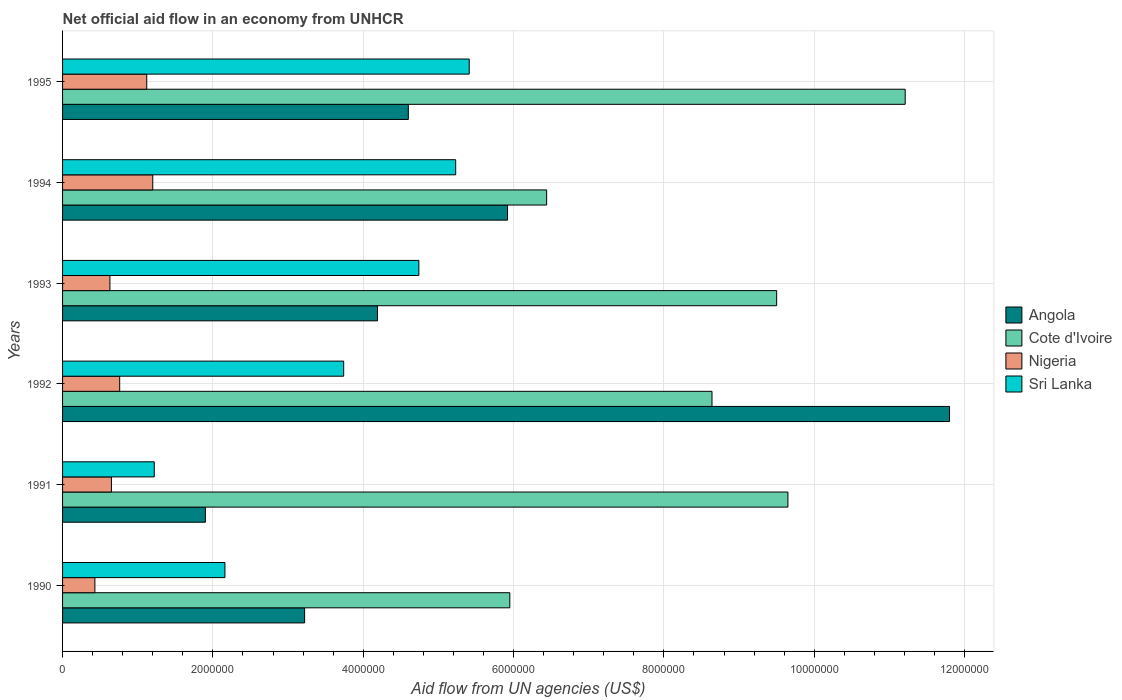How many different coloured bars are there?
Offer a terse response. 4. How many groups of bars are there?
Your answer should be compact. 6. Are the number of bars per tick equal to the number of legend labels?
Offer a very short reply. Yes. How many bars are there on the 5th tick from the bottom?
Offer a very short reply. 4. In how many cases, is the number of bars for a given year not equal to the number of legend labels?
Your response must be concise. 0. Across all years, what is the maximum net official aid flow in Sri Lanka?
Your answer should be compact. 5.41e+06. Across all years, what is the minimum net official aid flow in Angola?
Ensure brevity in your answer.  1.90e+06. In which year was the net official aid flow in Cote d'Ivoire maximum?
Your response must be concise. 1995. In which year was the net official aid flow in Angola minimum?
Provide a succinct answer. 1991. What is the total net official aid flow in Nigeria in the graph?
Offer a very short reply. 4.79e+06. What is the difference between the net official aid flow in Sri Lanka in 1990 and that in 1993?
Keep it short and to the point. -2.58e+06. What is the difference between the net official aid flow in Cote d'Ivoire in 1992 and the net official aid flow in Sri Lanka in 1995?
Keep it short and to the point. 3.23e+06. What is the average net official aid flow in Angola per year?
Give a very brief answer. 5.27e+06. In the year 1994, what is the difference between the net official aid flow in Cote d'Ivoire and net official aid flow in Angola?
Make the answer very short. 5.20e+05. In how many years, is the net official aid flow in Nigeria greater than 9600000 US$?
Provide a short and direct response. 0. What is the ratio of the net official aid flow in Sri Lanka in 1993 to that in 1994?
Make the answer very short. 0.91. Is the net official aid flow in Sri Lanka in 1990 less than that in 1991?
Make the answer very short. No. Is the difference between the net official aid flow in Cote d'Ivoire in 1990 and 1994 greater than the difference between the net official aid flow in Angola in 1990 and 1994?
Offer a terse response. Yes. What is the difference between the highest and the second highest net official aid flow in Angola?
Provide a succinct answer. 5.88e+06. What is the difference between the highest and the lowest net official aid flow in Angola?
Your answer should be very brief. 9.90e+06. What does the 1st bar from the top in 1992 represents?
Ensure brevity in your answer.  Sri Lanka. What does the 4th bar from the bottom in 1992 represents?
Provide a succinct answer. Sri Lanka. Are all the bars in the graph horizontal?
Provide a short and direct response. Yes. What is the difference between two consecutive major ticks on the X-axis?
Keep it short and to the point. 2.00e+06. Are the values on the major ticks of X-axis written in scientific E-notation?
Ensure brevity in your answer.  No. Does the graph contain any zero values?
Your answer should be very brief. No. Does the graph contain grids?
Provide a succinct answer. Yes. Where does the legend appear in the graph?
Provide a short and direct response. Center right. What is the title of the graph?
Ensure brevity in your answer.  Net official aid flow in an economy from UNHCR. What is the label or title of the X-axis?
Offer a terse response. Aid flow from UN agencies (US$). What is the Aid flow from UN agencies (US$) in Angola in 1990?
Provide a short and direct response. 3.22e+06. What is the Aid flow from UN agencies (US$) of Cote d'Ivoire in 1990?
Offer a terse response. 5.95e+06. What is the Aid flow from UN agencies (US$) of Sri Lanka in 1990?
Provide a succinct answer. 2.16e+06. What is the Aid flow from UN agencies (US$) of Angola in 1991?
Your response must be concise. 1.90e+06. What is the Aid flow from UN agencies (US$) in Cote d'Ivoire in 1991?
Make the answer very short. 9.65e+06. What is the Aid flow from UN agencies (US$) in Nigeria in 1991?
Offer a terse response. 6.50e+05. What is the Aid flow from UN agencies (US$) of Sri Lanka in 1991?
Your response must be concise. 1.22e+06. What is the Aid flow from UN agencies (US$) of Angola in 1992?
Offer a very short reply. 1.18e+07. What is the Aid flow from UN agencies (US$) of Cote d'Ivoire in 1992?
Provide a succinct answer. 8.64e+06. What is the Aid flow from UN agencies (US$) in Nigeria in 1992?
Provide a succinct answer. 7.60e+05. What is the Aid flow from UN agencies (US$) in Sri Lanka in 1992?
Your answer should be compact. 3.74e+06. What is the Aid flow from UN agencies (US$) in Angola in 1993?
Provide a succinct answer. 4.19e+06. What is the Aid flow from UN agencies (US$) of Cote d'Ivoire in 1993?
Your answer should be compact. 9.50e+06. What is the Aid flow from UN agencies (US$) of Nigeria in 1993?
Provide a short and direct response. 6.30e+05. What is the Aid flow from UN agencies (US$) in Sri Lanka in 1993?
Offer a terse response. 4.74e+06. What is the Aid flow from UN agencies (US$) in Angola in 1994?
Keep it short and to the point. 5.92e+06. What is the Aid flow from UN agencies (US$) of Cote d'Ivoire in 1994?
Offer a terse response. 6.44e+06. What is the Aid flow from UN agencies (US$) in Nigeria in 1994?
Make the answer very short. 1.20e+06. What is the Aid flow from UN agencies (US$) of Sri Lanka in 1994?
Ensure brevity in your answer.  5.23e+06. What is the Aid flow from UN agencies (US$) in Angola in 1995?
Give a very brief answer. 4.60e+06. What is the Aid flow from UN agencies (US$) of Cote d'Ivoire in 1995?
Make the answer very short. 1.12e+07. What is the Aid flow from UN agencies (US$) of Nigeria in 1995?
Your response must be concise. 1.12e+06. What is the Aid flow from UN agencies (US$) of Sri Lanka in 1995?
Keep it short and to the point. 5.41e+06. Across all years, what is the maximum Aid flow from UN agencies (US$) of Angola?
Ensure brevity in your answer.  1.18e+07. Across all years, what is the maximum Aid flow from UN agencies (US$) in Cote d'Ivoire?
Offer a very short reply. 1.12e+07. Across all years, what is the maximum Aid flow from UN agencies (US$) of Nigeria?
Provide a short and direct response. 1.20e+06. Across all years, what is the maximum Aid flow from UN agencies (US$) in Sri Lanka?
Give a very brief answer. 5.41e+06. Across all years, what is the minimum Aid flow from UN agencies (US$) of Angola?
Make the answer very short. 1.90e+06. Across all years, what is the minimum Aid flow from UN agencies (US$) of Cote d'Ivoire?
Make the answer very short. 5.95e+06. Across all years, what is the minimum Aid flow from UN agencies (US$) of Sri Lanka?
Give a very brief answer. 1.22e+06. What is the total Aid flow from UN agencies (US$) in Angola in the graph?
Give a very brief answer. 3.16e+07. What is the total Aid flow from UN agencies (US$) in Cote d'Ivoire in the graph?
Your response must be concise. 5.14e+07. What is the total Aid flow from UN agencies (US$) of Nigeria in the graph?
Keep it short and to the point. 4.79e+06. What is the total Aid flow from UN agencies (US$) of Sri Lanka in the graph?
Offer a very short reply. 2.25e+07. What is the difference between the Aid flow from UN agencies (US$) of Angola in 1990 and that in 1991?
Provide a succinct answer. 1.32e+06. What is the difference between the Aid flow from UN agencies (US$) in Cote d'Ivoire in 1990 and that in 1991?
Your answer should be very brief. -3.70e+06. What is the difference between the Aid flow from UN agencies (US$) of Sri Lanka in 1990 and that in 1991?
Make the answer very short. 9.40e+05. What is the difference between the Aid flow from UN agencies (US$) of Angola in 1990 and that in 1992?
Provide a short and direct response. -8.58e+06. What is the difference between the Aid flow from UN agencies (US$) in Cote d'Ivoire in 1990 and that in 1992?
Your answer should be compact. -2.69e+06. What is the difference between the Aid flow from UN agencies (US$) in Nigeria in 1990 and that in 1992?
Your answer should be very brief. -3.30e+05. What is the difference between the Aid flow from UN agencies (US$) of Sri Lanka in 1990 and that in 1992?
Give a very brief answer. -1.58e+06. What is the difference between the Aid flow from UN agencies (US$) of Angola in 1990 and that in 1993?
Your response must be concise. -9.70e+05. What is the difference between the Aid flow from UN agencies (US$) in Cote d'Ivoire in 1990 and that in 1993?
Give a very brief answer. -3.55e+06. What is the difference between the Aid flow from UN agencies (US$) of Nigeria in 1990 and that in 1993?
Give a very brief answer. -2.00e+05. What is the difference between the Aid flow from UN agencies (US$) of Sri Lanka in 1990 and that in 1993?
Provide a short and direct response. -2.58e+06. What is the difference between the Aid flow from UN agencies (US$) of Angola in 1990 and that in 1994?
Provide a succinct answer. -2.70e+06. What is the difference between the Aid flow from UN agencies (US$) in Cote d'Ivoire in 1990 and that in 1994?
Give a very brief answer. -4.90e+05. What is the difference between the Aid flow from UN agencies (US$) in Nigeria in 1990 and that in 1994?
Ensure brevity in your answer.  -7.70e+05. What is the difference between the Aid flow from UN agencies (US$) of Sri Lanka in 1990 and that in 1994?
Make the answer very short. -3.07e+06. What is the difference between the Aid flow from UN agencies (US$) of Angola in 1990 and that in 1995?
Provide a short and direct response. -1.38e+06. What is the difference between the Aid flow from UN agencies (US$) in Cote d'Ivoire in 1990 and that in 1995?
Make the answer very short. -5.26e+06. What is the difference between the Aid flow from UN agencies (US$) of Nigeria in 1990 and that in 1995?
Offer a very short reply. -6.90e+05. What is the difference between the Aid flow from UN agencies (US$) in Sri Lanka in 1990 and that in 1995?
Offer a very short reply. -3.25e+06. What is the difference between the Aid flow from UN agencies (US$) in Angola in 1991 and that in 1992?
Offer a terse response. -9.90e+06. What is the difference between the Aid flow from UN agencies (US$) in Cote d'Ivoire in 1991 and that in 1992?
Make the answer very short. 1.01e+06. What is the difference between the Aid flow from UN agencies (US$) of Sri Lanka in 1991 and that in 1992?
Offer a terse response. -2.52e+06. What is the difference between the Aid flow from UN agencies (US$) of Angola in 1991 and that in 1993?
Give a very brief answer. -2.29e+06. What is the difference between the Aid flow from UN agencies (US$) of Sri Lanka in 1991 and that in 1993?
Make the answer very short. -3.52e+06. What is the difference between the Aid flow from UN agencies (US$) in Angola in 1991 and that in 1994?
Offer a terse response. -4.02e+06. What is the difference between the Aid flow from UN agencies (US$) in Cote d'Ivoire in 1991 and that in 1994?
Offer a very short reply. 3.21e+06. What is the difference between the Aid flow from UN agencies (US$) of Nigeria in 1991 and that in 1994?
Provide a succinct answer. -5.50e+05. What is the difference between the Aid flow from UN agencies (US$) in Sri Lanka in 1991 and that in 1994?
Your response must be concise. -4.01e+06. What is the difference between the Aid flow from UN agencies (US$) of Angola in 1991 and that in 1995?
Ensure brevity in your answer.  -2.70e+06. What is the difference between the Aid flow from UN agencies (US$) in Cote d'Ivoire in 1991 and that in 1995?
Your answer should be very brief. -1.56e+06. What is the difference between the Aid flow from UN agencies (US$) in Nigeria in 1991 and that in 1995?
Offer a very short reply. -4.70e+05. What is the difference between the Aid flow from UN agencies (US$) in Sri Lanka in 1991 and that in 1995?
Provide a succinct answer. -4.19e+06. What is the difference between the Aid flow from UN agencies (US$) of Angola in 1992 and that in 1993?
Offer a terse response. 7.61e+06. What is the difference between the Aid flow from UN agencies (US$) in Cote d'Ivoire in 1992 and that in 1993?
Keep it short and to the point. -8.60e+05. What is the difference between the Aid flow from UN agencies (US$) in Angola in 1992 and that in 1994?
Your answer should be compact. 5.88e+06. What is the difference between the Aid flow from UN agencies (US$) in Cote d'Ivoire in 1992 and that in 1994?
Your response must be concise. 2.20e+06. What is the difference between the Aid flow from UN agencies (US$) in Nigeria in 1992 and that in 1994?
Offer a very short reply. -4.40e+05. What is the difference between the Aid flow from UN agencies (US$) of Sri Lanka in 1992 and that in 1994?
Give a very brief answer. -1.49e+06. What is the difference between the Aid flow from UN agencies (US$) of Angola in 1992 and that in 1995?
Offer a terse response. 7.20e+06. What is the difference between the Aid flow from UN agencies (US$) of Cote d'Ivoire in 1992 and that in 1995?
Your answer should be very brief. -2.57e+06. What is the difference between the Aid flow from UN agencies (US$) in Nigeria in 1992 and that in 1995?
Offer a very short reply. -3.60e+05. What is the difference between the Aid flow from UN agencies (US$) of Sri Lanka in 1992 and that in 1995?
Give a very brief answer. -1.67e+06. What is the difference between the Aid flow from UN agencies (US$) of Angola in 1993 and that in 1994?
Keep it short and to the point. -1.73e+06. What is the difference between the Aid flow from UN agencies (US$) in Cote d'Ivoire in 1993 and that in 1994?
Ensure brevity in your answer.  3.06e+06. What is the difference between the Aid flow from UN agencies (US$) of Nigeria in 1993 and that in 1994?
Provide a short and direct response. -5.70e+05. What is the difference between the Aid flow from UN agencies (US$) of Sri Lanka in 1993 and that in 1994?
Your answer should be compact. -4.90e+05. What is the difference between the Aid flow from UN agencies (US$) of Angola in 1993 and that in 1995?
Make the answer very short. -4.10e+05. What is the difference between the Aid flow from UN agencies (US$) of Cote d'Ivoire in 1993 and that in 1995?
Your response must be concise. -1.71e+06. What is the difference between the Aid flow from UN agencies (US$) in Nigeria in 1993 and that in 1995?
Keep it short and to the point. -4.90e+05. What is the difference between the Aid flow from UN agencies (US$) in Sri Lanka in 1993 and that in 1995?
Your answer should be very brief. -6.70e+05. What is the difference between the Aid flow from UN agencies (US$) of Angola in 1994 and that in 1995?
Make the answer very short. 1.32e+06. What is the difference between the Aid flow from UN agencies (US$) of Cote d'Ivoire in 1994 and that in 1995?
Make the answer very short. -4.77e+06. What is the difference between the Aid flow from UN agencies (US$) of Sri Lanka in 1994 and that in 1995?
Ensure brevity in your answer.  -1.80e+05. What is the difference between the Aid flow from UN agencies (US$) of Angola in 1990 and the Aid flow from UN agencies (US$) of Cote d'Ivoire in 1991?
Your answer should be compact. -6.43e+06. What is the difference between the Aid flow from UN agencies (US$) of Angola in 1990 and the Aid flow from UN agencies (US$) of Nigeria in 1991?
Your answer should be very brief. 2.57e+06. What is the difference between the Aid flow from UN agencies (US$) in Cote d'Ivoire in 1990 and the Aid flow from UN agencies (US$) in Nigeria in 1991?
Ensure brevity in your answer.  5.30e+06. What is the difference between the Aid flow from UN agencies (US$) of Cote d'Ivoire in 1990 and the Aid flow from UN agencies (US$) of Sri Lanka in 1991?
Your response must be concise. 4.73e+06. What is the difference between the Aid flow from UN agencies (US$) of Nigeria in 1990 and the Aid flow from UN agencies (US$) of Sri Lanka in 1991?
Offer a terse response. -7.90e+05. What is the difference between the Aid flow from UN agencies (US$) in Angola in 1990 and the Aid flow from UN agencies (US$) in Cote d'Ivoire in 1992?
Offer a very short reply. -5.42e+06. What is the difference between the Aid flow from UN agencies (US$) in Angola in 1990 and the Aid flow from UN agencies (US$) in Nigeria in 1992?
Your answer should be very brief. 2.46e+06. What is the difference between the Aid flow from UN agencies (US$) in Angola in 1990 and the Aid flow from UN agencies (US$) in Sri Lanka in 1992?
Ensure brevity in your answer.  -5.20e+05. What is the difference between the Aid flow from UN agencies (US$) of Cote d'Ivoire in 1990 and the Aid flow from UN agencies (US$) of Nigeria in 1992?
Keep it short and to the point. 5.19e+06. What is the difference between the Aid flow from UN agencies (US$) in Cote d'Ivoire in 1990 and the Aid flow from UN agencies (US$) in Sri Lanka in 1992?
Your answer should be very brief. 2.21e+06. What is the difference between the Aid flow from UN agencies (US$) in Nigeria in 1990 and the Aid flow from UN agencies (US$) in Sri Lanka in 1992?
Keep it short and to the point. -3.31e+06. What is the difference between the Aid flow from UN agencies (US$) in Angola in 1990 and the Aid flow from UN agencies (US$) in Cote d'Ivoire in 1993?
Offer a terse response. -6.28e+06. What is the difference between the Aid flow from UN agencies (US$) of Angola in 1990 and the Aid flow from UN agencies (US$) of Nigeria in 1993?
Provide a succinct answer. 2.59e+06. What is the difference between the Aid flow from UN agencies (US$) of Angola in 1990 and the Aid flow from UN agencies (US$) of Sri Lanka in 1993?
Your answer should be compact. -1.52e+06. What is the difference between the Aid flow from UN agencies (US$) of Cote d'Ivoire in 1990 and the Aid flow from UN agencies (US$) of Nigeria in 1993?
Give a very brief answer. 5.32e+06. What is the difference between the Aid flow from UN agencies (US$) of Cote d'Ivoire in 1990 and the Aid flow from UN agencies (US$) of Sri Lanka in 1993?
Provide a succinct answer. 1.21e+06. What is the difference between the Aid flow from UN agencies (US$) of Nigeria in 1990 and the Aid flow from UN agencies (US$) of Sri Lanka in 1993?
Your answer should be very brief. -4.31e+06. What is the difference between the Aid flow from UN agencies (US$) in Angola in 1990 and the Aid flow from UN agencies (US$) in Cote d'Ivoire in 1994?
Give a very brief answer. -3.22e+06. What is the difference between the Aid flow from UN agencies (US$) of Angola in 1990 and the Aid flow from UN agencies (US$) of Nigeria in 1994?
Ensure brevity in your answer.  2.02e+06. What is the difference between the Aid flow from UN agencies (US$) of Angola in 1990 and the Aid flow from UN agencies (US$) of Sri Lanka in 1994?
Your answer should be compact. -2.01e+06. What is the difference between the Aid flow from UN agencies (US$) in Cote d'Ivoire in 1990 and the Aid flow from UN agencies (US$) in Nigeria in 1994?
Your answer should be compact. 4.75e+06. What is the difference between the Aid flow from UN agencies (US$) of Cote d'Ivoire in 1990 and the Aid flow from UN agencies (US$) of Sri Lanka in 1994?
Provide a short and direct response. 7.20e+05. What is the difference between the Aid flow from UN agencies (US$) of Nigeria in 1990 and the Aid flow from UN agencies (US$) of Sri Lanka in 1994?
Make the answer very short. -4.80e+06. What is the difference between the Aid flow from UN agencies (US$) of Angola in 1990 and the Aid flow from UN agencies (US$) of Cote d'Ivoire in 1995?
Your answer should be very brief. -7.99e+06. What is the difference between the Aid flow from UN agencies (US$) in Angola in 1990 and the Aid flow from UN agencies (US$) in Nigeria in 1995?
Give a very brief answer. 2.10e+06. What is the difference between the Aid flow from UN agencies (US$) of Angola in 1990 and the Aid flow from UN agencies (US$) of Sri Lanka in 1995?
Your response must be concise. -2.19e+06. What is the difference between the Aid flow from UN agencies (US$) of Cote d'Ivoire in 1990 and the Aid flow from UN agencies (US$) of Nigeria in 1995?
Provide a succinct answer. 4.83e+06. What is the difference between the Aid flow from UN agencies (US$) in Cote d'Ivoire in 1990 and the Aid flow from UN agencies (US$) in Sri Lanka in 1995?
Provide a succinct answer. 5.40e+05. What is the difference between the Aid flow from UN agencies (US$) in Nigeria in 1990 and the Aid flow from UN agencies (US$) in Sri Lanka in 1995?
Keep it short and to the point. -4.98e+06. What is the difference between the Aid flow from UN agencies (US$) of Angola in 1991 and the Aid flow from UN agencies (US$) of Cote d'Ivoire in 1992?
Your answer should be compact. -6.74e+06. What is the difference between the Aid flow from UN agencies (US$) of Angola in 1991 and the Aid flow from UN agencies (US$) of Nigeria in 1992?
Your answer should be very brief. 1.14e+06. What is the difference between the Aid flow from UN agencies (US$) of Angola in 1991 and the Aid flow from UN agencies (US$) of Sri Lanka in 1992?
Your answer should be compact. -1.84e+06. What is the difference between the Aid flow from UN agencies (US$) of Cote d'Ivoire in 1991 and the Aid flow from UN agencies (US$) of Nigeria in 1992?
Ensure brevity in your answer.  8.89e+06. What is the difference between the Aid flow from UN agencies (US$) of Cote d'Ivoire in 1991 and the Aid flow from UN agencies (US$) of Sri Lanka in 1992?
Give a very brief answer. 5.91e+06. What is the difference between the Aid flow from UN agencies (US$) of Nigeria in 1991 and the Aid flow from UN agencies (US$) of Sri Lanka in 1992?
Provide a succinct answer. -3.09e+06. What is the difference between the Aid flow from UN agencies (US$) of Angola in 1991 and the Aid flow from UN agencies (US$) of Cote d'Ivoire in 1993?
Your response must be concise. -7.60e+06. What is the difference between the Aid flow from UN agencies (US$) of Angola in 1991 and the Aid flow from UN agencies (US$) of Nigeria in 1993?
Make the answer very short. 1.27e+06. What is the difference between the Aid flow from UN agencies (US$) in Angola in 1991 and the Aid flow from UN agencies (US$) in Sri Lanka in 1993?
Ensure brevity in your answer.  -2.84e+06. What is the difference between the Aid flow from UN agencies (US$) of Cote d'Ivoire in 1991 and the Aid flow from UN agencies (US$) of Nigeria in 1993?
Your answer should be very brief. 9.02e+06. What is the difference between the Aid flow from UN agencies (US$) in Cote d'Ivoire in 1991 and the Aid flow from UN agencies (US$) in Sri Lanka in 1993?
Make the answer very short. 4.91e+06. What is the difference between the Aid flow from UN agencies (US$) of Nigeria in 1991 and the Aid flow from UN agencies (US$) of Sri Lanka in 1993?
Your answer should be very brief. -4.09e+06. What is the difference between the Aid flow from UN agencies (US$) of Angola in 1991 and the Aid flow from UN agencies (US$) of Cote d'Ivoire in 1994?
Your response must be concise. -4.54e+06. What is the difference between the Aid flow from UN agencies (US$) in Angola in 1991 and the Aid flow from UN agencies (US$) in Nigeria in 1994?
Ensure brevity in your answer.  7.00e+05. What is the difference between the Aid flow from UN agencies (US$) of Angola in 1991 and the Aid flow from UN agencies (US$) of Sri Lanka in 1994?
Offer a very short reply. -3.33e+06. What is the difference between the Aid flow from UN agencies (US$) in Cote d'Ivoire in 1991 and the Aid flow from UN agencies (US$) in Nigeria in 1994?
Ensure brevity in your answer.  8.45e+06. What is the difference between the Aid flow from UN agencies (US$) in Cote d'Ivoire in 1991 and the Aid flow from UN agencies (US$) in Sri Lanka in 1994?
Your answer should be compact. 4.42e+06. What is the difference between the Aid flow from UN agencies (US$) in Nigeria in 1991 and the Aid flow from UN agencies (US$) in Sri Lanka in 1994?
Ensure brevity in your answer.  -4.58e+06. What is the difference between the Aid flow from UN agencies (US$) in Angola in 1991 and the Aid flow from UN agencies (US$) in Cote d'Ivoire in 1995?
Keep it short and to the point. -9.31e+06. What is the difference between the Aid flow from UN agencies (US$) of Angola in 1991 and the Aid flow from UN agencies (US$) of Nigeria in 1995?
Ensure brevity in your answer.  7.80e+05. What is the difference between the Aid flow from UN agencies (US$) of Angola in 1991 and the Aid flow from UN agencies (US$) of Sri Lanka in 1995?
Your response must be concise. -3.51e+06. What is the difference between the Aid flow from UN agencies (US$) in Cote d'Ivoire in 1991 and the Aid flow from UN agencies (US$) in Nigeria in 1995?
Make the answer very short. 8.53e+06. What is the difference between the Aid flow from UN agencies (US$) in Cote d'Ivoire in 1991 and the Aid flow from UN agencies (US$) in Sri Lanka in 1995?
Your answer should be very brief. 4.24e+06. What is the difference between the Aid flow from UN agencies (US$) of Nigeria in 1991 and the Aid flow from UN agencies (US$) of Sri Lanka in 1995?
Make the answer very short. -4.76e+06. What is the difference between the Aid flow from UN agencies (US$) in Angola in 1992 and the Aid flow from UN agencies (US$) in Cote d'Ivoire in 1993?
Offer a terse response. 2.30e+06. What is the difference between the Aid flow from UN agencies (US$) in Angola in 1992 and the Aid flow from UN agencies (US$) in Nigeria in 1993?
Keep it short and to the point. 1.12e+07. What is the difference between the Aid flow from UN agencies (US$) in Angola in 1992 and the Aid flow from UN agencies (US$) in Sri Lanka in 1993?
Make the answer very short. 7.06e+06. What is the difference between the Aid flow from UN agencies (US$) in Cote d'Ivoire in 1992 and the Aid flow from UN agencies (US$) in Nigeria in 1993?
Your answer should be compact. 8.01e+06. What is the difference between the Aid flow from UN agencies (US$) in Cote d'Ivoire in 1992 and the Aid flow from UN agencies (US$) in Sri Lanka in 1993?
Make the answer very short. 3.90e+06. What is the difference between the Aid flow from UN agencies (US$) in Nigeria in 1992 and the Aid flow from UN agencies (US$) in Sri Lanka in 1993?
Give a very brief answer. -3.98e+06. What is the difference between the Aid flow from UN agencies (US$) in Angola in 1992 and the Aid flow from UN agencies (US$) in Cote d'Ivoire in 1994?
Your answer should be very brief. 5.36e+06. What is the difference between the Aid flow from UN agencies (US$) in Angola in 1992 and the Aid flow from UN agencies (US$) in Nigeria in 1994?
Provide a succinct answer. 1.06e+07. What is the difference between the Aid flow from UN agencies (US$) of Angola in 1992 and the Aid flow from UN agencies (US$) of Sri Lanka in 1994?
Offer a terse response. 6.57e+06. What is the difference between the Aid flow from UN agencies (US$) in Cote d'Ivoire in 1992 and the Aid flow from UN agencies (US$) in Nigeria in 1994?
Keep it short and to the point. 7.44e+06. What is the difference between the Aid flow from UN agencies (US$) in Cote d'Ivoire in 1992 and the Aid flow from UN agencies (US$) in Sri Lanka in 1994?
Give a very brief answer. 3.41e+06. What is the difference between the Aid flow from UN agencies (US$) in Nigeria in 1992 and the Aid flow from UN agencies (US$) in Sri Lanka in 1994?
Your answer should be compact. -4.47e+06. What is the difference between the Aid flow from UN agencies (US$) in Angola in 1992 and the Aid flow from UN agencies (US$) in Cote d'Ivoire in 1995?
Give a very brief answer. 5.90e+05. What is the difference between the Aid flow from UN agencies (US$) in Angola in 1992 and the Aid flow from UN agencies (US$) in Nigeria in 1995?
Ensure brevity in your answer.  1.07e+07. What is the difference between the Aid flow from UN agencies (US$) of Angola in 1992 and the Aid flow from UN agencies (US$) of Sri Lanka in 1995?
Keep it short and to the point. 6.39e+06. What is the difference between the Aid flow from UN agencies (US$) of Cote d'Ivoire in 1992 and the Aid flow from UN agencies (US$) of Nigeria in 1995?
Ensure brevity in your answer.  7.52e+06. What is the difference between the Aid flow from UN agencies (US$) of Cote d'Ivoire in 1992 and the Aid flow from UN agencies (US$) of Sri Lanka in 1995?
Make the answer very short. 3.23e+06. What is the difference between the Aid flow from UN agencies (US$) of Nigeria in 1992 and the Aid flow from UN agencies (US$) of Sri Lanka in 1995?
Keep it short and to the point. -4.65e+06. What is the difference between the Aid flow from UN agencies (US$) of Angola in 1993 and the Aid flow from UN agencies (US$) of Cote d'Ivoire in 1994?
Your answer should be compact. -2.25e+06. What is the difference between the Aid flow from UN agencies (US$) in Angola in 1993 and the Aid flow from UN agencies (US$) in Nigeria in 1994?
Give a very brief answer. 2.99e+06. What is the difference between the Aid flow from UN agencies (US$) in Angola in 1993 and the Aid flow from UN agencies (US$) in Sri Lanka in 1994?
Keep it short and to the point. -1.04e+06. What is the difference between the Aid flow from UN agencies (US$) of Cote d'Ivoire in 1993 and the Aid flow from UN agencies (US$) of Nigeria in 1994?
Give a very brief answer. 8.30e+06. What is the difference between the Aid flow from UN agencies (US$) in Cote d'Ivoire in 1993 and the Aid flow from UN agencies (US$) in Sri Lanka in 1994?
Offer a very short reply. 4.27e+06. What is the difference between the Aid flow from UN agencies (US$) of Nigeria in 1993 and the Aid flow from UN agencies (US$) of Sri Lanka in 1994?
Ensure brevity in your answer.  -4.60e+06. What is the difference between the Aid flow from UN agencies (US$) in Angola in 1993 and the Aid flow from UN agencies (US$) in Cote d'Ivoire in 1995?
Your answer should be compact. -7.02e+06. What is the difference between the Aid flow from UN agencies (US$) of Angola in 1993 and the Aid flow from UN agencies (US$) of Nigeria in 1995?
Offer a terse response. 3.07e+06. What is the difference between the Aid flow from UN agencies (US$) in Angola in 1993 and the Aid flow from UN agencies (US$) in Sri Lanka in 1995?
Your answer should be very brief. -1.22e+06. What is the difference between the Aid flow from UN agencies (US$) in Cote d'Ivoire in 1993 and the Aid flow from UN agencies (US$) in Nigeria in 1995?
Offer a terse response. 8.38e+06. What is the difference between the Aid flow from UN agencies (US$) in Cote d'Ivoire in 1993 and the Aid flow from UN agencies (US$) in Sri Lanka in 1995?
Your answer should be compact. 4.09e+06. What is the difference between the Aid flow from UN agencies (US$) of Nigeria in 1993 and the Aid flow from UN agencies (US$) of Sri Lanka in 1995?
Provide a short and direct response. -4.78e+06. What is the difference between the Aid flow from UN agencies (US$) in Angola in 1994 and the Aid flow from UN agencies (US$) in Cote d'Ivoire in 1995?
Offer a very short reply. -5.29e+06. What is the difference between the Aid flow from UN agencies (US$) of Angola in 1994 and the Aid flow from UN agencies (US$) of Nigeria in 1995?
Offer a very short reply. 4.80e+06. What is the difference between the Aid flow from UN agencies (US$) in Angola in 1994 and the Aid flow from UN agencies (US$) in Sri Lanka in 1995?
Your answer should be very brief. 5.10e+05. What is the difference between the Aid flow from UN agencies (US$) in Cote d'Ivoire in 1994 and the Aid flow from UN agencies (US$) in Nigeria in 1995?
Offer a terse response. 5.32e+06. What is the difference between the Aid flow from UN agencies (US$) in Cote d'Ivoire in 1994 and the Aid flow from UN agencies (US$) in Sri Lanka in 1995?
Your answer should be compact. 1.03e+06. What is the difference between the Aid flow from UN agencies (US$) in Nigeria in 1994 and the Aid flow from UN agencies (US$) in Sri Lanka in 1995?
Your answer should be compact. -4.21e+06. What is the average Aid flow from UN agencies (US$) of Angola per year?
Give a very brief answer. 5.27e+06. What is the average Aid flow from UN agencies (US$) in Cote d'Ivoire per year?
Provide a succinct answer. 8.56e+06. What is the average Aid flow from UN agencies (US$) in Nigeria per year?
Provide a short and direct response. 7.98e+05. What is the average Aid flow from UN agencies (US$) of Sri Lanka per year?
Offer a very short reply. 3.75e+06. In the year 1990, what is the difference between the Aid flow from UN agencies (US$) of Angola and Aid flow from UN agencies (US$) of Cote d'Ivoire?
Provide a succinct answer. -2.73e+06. In the year 1990, what is the difference between the Aid flow from UN agencies (US$) of Angola and Aid flow from UN agencies (US$) of Nigeria?
Your answer should be very brief. 2.79e+06. In the year 1990, what is the difference between the Aid flow from UN agencies (US$) in Angola and Aid flow from UN agencies (US$) in Sri Lanka?
Make the answer very short. 1.06e+06. In the year 1990, what is the difference between the Aid flow from UN agencies (US$) in Cote d'Ivoire and Aid flow from UN agencies (US$) in Nigeria?
Provide a short and direct response. 5.52e+06. In the year 1990, what is the difference between the Aid flow from UN agencies (US$) in Cote d'Ivoire and Aid flow from UN agencies (US$) in Sri Lanka?
Your answer should be very brief. 3.79e+06. In the year 1990, what is the difference between the Aid flow from UN agencies (US$) of Nigeria and Aid flow from UN agencies (US$) of Sri Lanka?
Make the answer very short. -1.73e+06. In the year 1991, what is the difference between the Aid flow from UN agencies (US$) of Angola and Aid flow from UN agencies (US$) of Cote d'Ivoire?
Your answer should be compact. -7.75e+06. In the year 1991, what is the difference between the Aid flow from UN agencies (US$) of Angola and Aid flow from UN agencies (US$) of Nigeria?
Keep it short and to the point. 1.25e+06. In the year 1991, what is the difference between the Aid flow from UN agencies (US$) of Angola and Aid flow from UN agencies (US$) of Sri Lanka?
Offer a terse response. 6.80e+05. In the year 1991, what is the difference between the Aid flow from UN agencies (US$) of Cote d'Ivoire and Aid flow from UN agencies (US$) of Nigeria?
Your answer should be compact. 9.00e+06. In the year 1991, what is the difference between the Aid flow from UN agencies (US$) of Cote d'Ivoire and Aid flow from UN agencies (US$) of Sri Lanka?
Your answer should be compact. 8.43e+06. In the year 1991, what is the difference between the Aid flow from UN agencies (US$) of Nigeria and Aid flow from UN agencies (US$) of Sri Lanka?
Give a very brief answer. -5.70e+05. In the year 1992, what is the difference between the Aid flow from UN agencies (US$) in Angola and Aid flow from UN agencies (US$) in Cote d'Ivoire?
Offer a terse response. 3.16e+06. In the year 1992, what is the difference between the Aid flow from UN agencies (US$) in Angola and Aid flow from UN agencies (US$) in Nigeria?
Keep it short and to the point. 1.10e+07. In the year 1992, what is the difference between the Aid flow from UN agencies (US$) of Angola and Aid flow from UN agencies (US$) of Sri Lanka?
Ensure brevity in your answer.  8.06e+06. In the year 1992, what is the difference between the Aid flow from UN agencies (US$) in Cote d'Ivoire and Aid flow from UN agencies (US$) in Nigeria?
Offer a terse response. 7.88e+06. In the year 1992, what is the difference between the Aid flow from UN agencies (US$) of Cote d'Ivoire and Aid flow from UN agencies (US$) of Sri Lanka?
Provide a succinct answer. 4.90e+06. In the year 1992, what is the difference between the Aid flow from UN agencies (US$) in Nigeria and Aid flow from UN agencies (US$) in Sri Lanka?
Give a very brief answer. -2.98e+06. In the year 1993, what is the difference between the Aid flow from UN agencies (US$) of Angola and Aid flow from UN agencies (US$) of Cote d'Ivoire?
Ensure brevity in your answer.  -5.31e+06. In the year 1993, what is the difference between the Aid flow from UN agencies (US$) in Angola and Aid flow from UN agencies (US$) in Nigeria?
Give a very brief answer. 3.56e+06. In the year 1993, what is the difference between the Aid flow from UN agencies (US$) of Angola and Aid flow from UN agencies (US$) of Sri Lanka?
Ensure brevity in your answer.  -5.50e+05. In the year 1993, what is the difference between the Aid flow from UN agencies (US$) of Cote d'Ivoire and Aid flow from UN agencies (US$) of Nigeria?
Offer a very short reply. 8.87e+06. In the year 1993, what is the difference between the Aid flow from UN agencies (US$) in Cote d'Ivoire and Aid flow from UN agencies (US$) in Sri Lanka?
Provide a short and direct response. 4.76e+06. In the year 1993, what is the difference between the Aid flow from UN agencies (US$) in Nigeria and Aid flow from UN agencies (US$) in Sri Lanka?
Offer a terse response. -4.11e+06. In the year 1994, what is the difference between the Aid flow from UN agencies (US$) in Angola and Aid flow from UN agencies (US$) in Cote d'Ivoire?
Your answer should be compact. -5.20e+05. In the year 1994, what is the difference between the Aid flow from UN agencies (US$) of Angola and Aid flow from UN agencies (US$) of Nigeria?
Provide a succinct answer. 4.72e+06. In the year 1994, what is the difference between the Aid flow from UN agencies (US$) in Angola and Aid flow from UN agencies (US$) in Sri Lanka?
Your response must be concise. 6.90e+05. In the year 1994, what is the difference between the Aid flow from UN agencies (US$) in Cote d'Ivoire and Aid flow from UN agencies (US$) in Nigeria?
Offer a terse response. 5.24e+06. In the year 1994, what is the difference between the Aid flow from UN agencies (US$) in Cote d'Ivoire and Aid flow from UN agencies (US$) in Sri Lanka?
Give a very brief answer. 1.21e+06. In the year 1994, what is the difference between the Aid flow from UN agencies (US$) in Nigeria and Aid flow from UN agencies (US$) in Sri Lanka?
Your response must be concise. -4.03e+06. In the year 1995, what is the difference between the Aid flow from UN agencies (US$) in Angola and Aid flow from UN agencies (US$) in Cote d'Ivoire?
Ensure brevity in your answer.  -6.61e+06. In the year 1995, what is the difference between the Aid flow from UN agencies (US$) of Angola and Aid flow from UN agencies (US$) of Nigeria?
Provide a short and direct response. 3.48e+06. In the year 1995, what is the difference between the Aid flow from UN agencies (US$) of Angola and Aid flow from UN agencies (US$) of Sri Lanka?
Keep it short and to the point. -8.10e+05. In the year 1995, what is the difference between the Aid flow from UN agencies (US$) in Cote d'Ivoire and Aid flow from UN agencies (US$) in Nigeria?
Provide a short and direct response. 1.01e+07. In the year 1995, what is the difference between the Aid flow from UN agencies (US$) of Cote d'Ivoire and Aid flow from UN agencies (US$) of Sri Lanka?
Give a very brief answer. 5.80e+06. In the year 1995, what is the difference between the Aid flow from UN agencies (US$) of Nigeria and Aid flow from UN agencies (US$) of Sri Lanka?
Provide a succinct answer. -4.29e+06. What is the ratio of the Aid flow from UN agencies (US$) of Angola in 1990 to that in 1991?
Give a very brief answer. 1.69. What is the ratio of the Aid flow from UN agencies (US$) in Cote d'Ivoire in 1990 to that in 1991?
Your response must be concise. 0.62. What is the ratio of the Aid flow from UN agencies (US$) in Nigeria in 1990 to that in 1991?
Provide a succinct answer. 0.66. What is the ratio of the Aid flow from UN agencies (US$) of Sri Lanka in 1990 to that in 1991?
Offer a very short reply. 1.77. What is the ratio of the Aid flow from UN agencies (US$) of Angola in 1990 to that in 1992?
Ensure brevity in your answer.  0.27. What is the ratio of the Aid flow from UN agencies (US$) in Cote d'Ivoire in 1990 to that in 1992?
Your response must be concise. 0.69. What is the ratio of the Aid flow from UN agencies (US$) in Nigeria in 1990 to that in 1992?
Provide a succinct answer. 0.57. What is the ratio of the Aid flow from UN agencies (US$) in Sri Lanka in 1990 to that in 1992?
Provide a succinct answer. 0.58. What is the ratio of the Aid flow from UN agencies (US$) of Angola in 1990 to that in 1993?
Provide a short and direct response. 0.77. What is the ratio of the Aid flow from UN agencies (US$) in Cote d'Ivoire in 1990 to that in 1993?
Provide a short and direct response. 0.63. What is the ratio of the Aid flow from UN agencies (US$) of Nigeria in 1990 to that in 1993?
Provide a succinct answer. 0.68. What is the ratio of the Aid flow from UN agencies (US$) of Sri Lanka in 1990 to that in 1993?
Keep it short and to the point. 0.46. What is the ratio of the Aid flow from UN agencies (US$) in Angola in 1990 to that in 1994?
Provide a succinct answer. 0.54. What is the ratio of the Aid flow from UN agencies (US$) in Cote d'Ivoire in 1990 to that in 1994?
Offer a very short reply. 0.92. What is the ratio of the Aid flow from UN agencies (US$) of Nigeria in 1990 to that in 1994?
Give a very brief answer. 0.36. What is the ratio of the Aid flow from UN agencies (US$) in Sri Lanka in 1990 to that in 1994?
Make the answer very short. 0.41. What is the ratio of the Aid flow from UN agencies (US$) of Angola in 1990 to that in 1995?
Give a very brief answer. 0.7. What is the ratio of the Aid flow from UN agencies (US$) in Cote d'Ivoire in 1990 to that in 1995?
Your response must be concise. 0.53. What is the ratio of the Aid flow from UN agencies (US$) in Nigeria in 1990 to that in 1995?
Keep it short and to the point. 0.38. What is the ratio of the Aid flow from UN agencies (US$) in Sri Lanka in 1990 to that in 1995?
Your answer should be very brief. 0.4. What is the ratio of the Aid flow from UN agencies (US$) in Angola in 1991 to that in 1992?
Offer a very short reply. 0.16. What is the ratio of the Aid flow from UN agencies (US$) of Cote d'Ivoire in 1991 to that in 1992?
Your response must be concise. 1.12. What is the ratio of the Aid flow from UN agencies (US$) of Nigeria in 1991 to that in 1992?
Give a very brief answer. 0.86. What is the ratio of the Aid flow from UN agencies (US$) in Sri Lanka in 1991 to that in 1992?
Provide a succinct answer. 0.33. What is the ratio of the Aid flow from UN agencies (US$) of Angola in 1991 to that in 1993?
Give a very brief answer. 0.45. What is the ratio of the Aid flow from UN agencies (US$) in Cote d'Ivoire in 1991 to that in 1993?
Your answer should be very brief. 1.02. What is the ratio of the Aid flow from UN agencies (US$) in Nigeria in 1991 to that in 1993?
Make the answer very short. 1.03. What is the ratio of the Aid flow from UN agencies (US$) of Sri Lanka in 1991 to that in 1993?
Your answer should be very brief. 0.26. What is the ratio of the Aid flow from UN agencies (US$) of Angola in 1991 to that in 1994?
Ensure brevity in your answer.  0.32. What is the ratio of the Aid flow from UN agencies (US$) in Cote d'Ivoire in 1991 to that in 1994?
Offer a very short reply. 1.5. What is the ratio of the Aid flow from UN agencies (US$) of Nigeria in 1991 to that in 1994?
Your response must be concise. 0.54. What is the ratio of the Aid flow from UN agencies (US$) in Sri Lanka in 1991 to that in 1994?
Your response must be concise. 0.23. What is the ratio of the Aid flow from UN agencies (US$) of Angola in 1991 to that in 1995?
Ensure brevity in your answer.  0.41. What is the ratio of the Aid flow from UN agencies (US$) of Cote d'Ivoire in 1991 to that in 1995?
Ensure brevity in your answer.  0.86. What is the ratio of the Aid flow from UN agencies (US$) in Nigeria in 1991 to that in 1995?
Provide a succinct answer. 0.58. What is the ratio of the Aid flow from UN agencies (US$) of Sri Lanka in 1991 to that in 1995?
Offer a terse response. 0.23. What is the ratio of the Aid flow from UN agencies (US$) in Angola in 1992 to that in 1993?
Provide a succinct answer. 2.82. What is the ratio of the Aid flow from UN agencies (US$) of Cote d'Ivoire in 1992 to that in 1993?
Make the answer very short. 0.91. What is the ratio of the Aid flow from UN agencies (US$) in Nigeria in 1992 to that in 1993?
Offer a terse response. 1.21. What is the ratio of the Aid flow from UN agencies (US$) of Sri Lanka in 1992 to that in 1993?
Your answer should be compact. 0.79. What is the ratio of the Aid flow from UN agencies (US$) in Angola in 1992 to that in 1994?
Your response must be concise. 1.99. What is the ratio of the Aid flow from UN agencies (US$) of Cote d'Ivoire in 1992 to that in 1994?
Provide a short and direct response. 1.34. What is the ratio of the Aid flow from UN agencies (US$) of Nigeria in 1992 to that in 1994?
Make the answer very short. 0.63. What is the ratio of the Aid flow from UN agencies (US$) of Sri Lanka in 1992 to that in 1994?
Make the answer very short. 0.72. What is the ratio of the Aid flow from UN agencies (US$) of Angola in 1992 to that in 1995?
Keep it short and to the point. 2.57. What is the ratio of the Aid flow from UN agencies (US$) in Cote d'Ivoire in 1992 to that in 1995?
Your response must be concise. 0.77. What is the ratio of the Aid flow from UN agencies (US$) in Nigeria in 1992 to that in 1995?
Your response must be concise. 0.68. What is the ratio of the Aid flow from UN agencies (US$) in Sri Lanka in 1992 to that in 1995?
Provide a short and direct response. 0.69. What is the ratio of the Aid flow from UN agencies (US$) in Angola in 1993 to that in 1994?
Provide a short and direct response. 0.71. What is the ratio of the Aid flow from UN agencies (US$) of Cote d'Ivoire in 1993 to that in 1994?
Offer a terse response. 1.48. What is the ratio of the Aid flow from UN agencies (US$) of Nigeria in 1993 to that in 1994?
Make the answer very short. 0.53. What is the ratio of the Aid flow from UN agencies (US$) in Sri Lanka in 1993 to that in 1994?
Offer a terse response. 0.91. What is the ratio of the Aid flow from UN agencies (US$) in Angola in 1993 to that in 1995?
Offer a very short reply. 0.91. What is the ratio of the Aid flow from UN agencies (US$) in Cote d'Ivoire in 1993 to that in 1995?
Provide a succinct answer. 0.85. What is the ratio of the Aid flow from UN agencies (US$) in Nigeria in 1993 to that in 1995?
Provide a short and direct response. 0.56. What is the ratio of the Aid flow from UN agencies (US$) of Sri Lanka in 1993 to that in 1995?
Offer a terse response. 0.88. What is the ratio of the Aid flow from UN agencies (US$) in Angola in 1994 to that in 1995?
Provide a short and direct response. 1.29. What is the ratio of the Aid flow from UN agencies (US$) in Cote d'Ivoire in 1994 to that in 1995?
Make the answer very short. 0.57. What is the ratio of the Aid flow from UN agencies (US$) of Nigeria in 1994 to that in 1995?
Make the answer very short. 1.07. What is the ratio of the Aid flow from UN agencies (US$) of Sri Lanka in 1994 to that in 1995?
Your answer should be very brief. 0.97. What is the difference between the highest and the second highest Aid flow from UN agencies (US$) in Angola?
Your answer should be compact. 5.88e+06. What is the difference between the highest and the second highest Aid flow from UN agencies (US$) of Cote d'Ivoire?
Keep it short and to the point. 1.56e+06. What is the difference between the highest and the second highest Aid flow from UN agencies (US$) in Nigeria?
Provide a short and direct response. 8.00e+04. What is the difference between the highest and the second highest Aid flow from UN agencies (US$) in Sri Lanka?
Your answer should be very brief. 1.80e+05. What is the difference between the highest and the lowest Aid flow from UN agencies (US$) of Angola?
Keep it short and to the point. 9.90e+06. What is the difference between the highest and the lowest Aid flow from UN agencies (US$) in Cote d'Ivoire?
Make the answer very short. 5.26e+06. What is the difference between the highest and the lowest Aid flow from UN agencies (US$) of Nigeria?
Your answer should be very brief. 7.70e+05. What is the difference between the highest and the lowest Aid flow from UN agencies (US$) in Sri Lanka?
Your answer should be compact. 4.19e+06. 